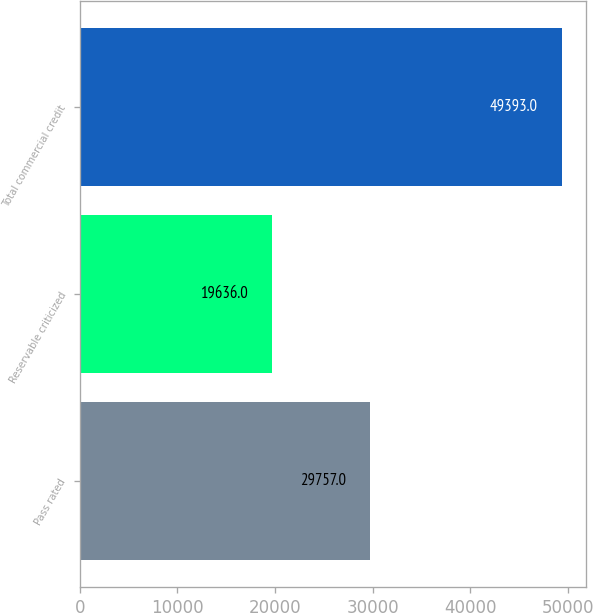Convert chart. <chart><loc_0><loc_0><loc_500><loc_500><bar_chart><fcel>Pass rated<fcel>Reservable criticized<fcel>Total commercial credit<nl><fcel>29757<fcel>19636<fcel>49393<nl></chart> 